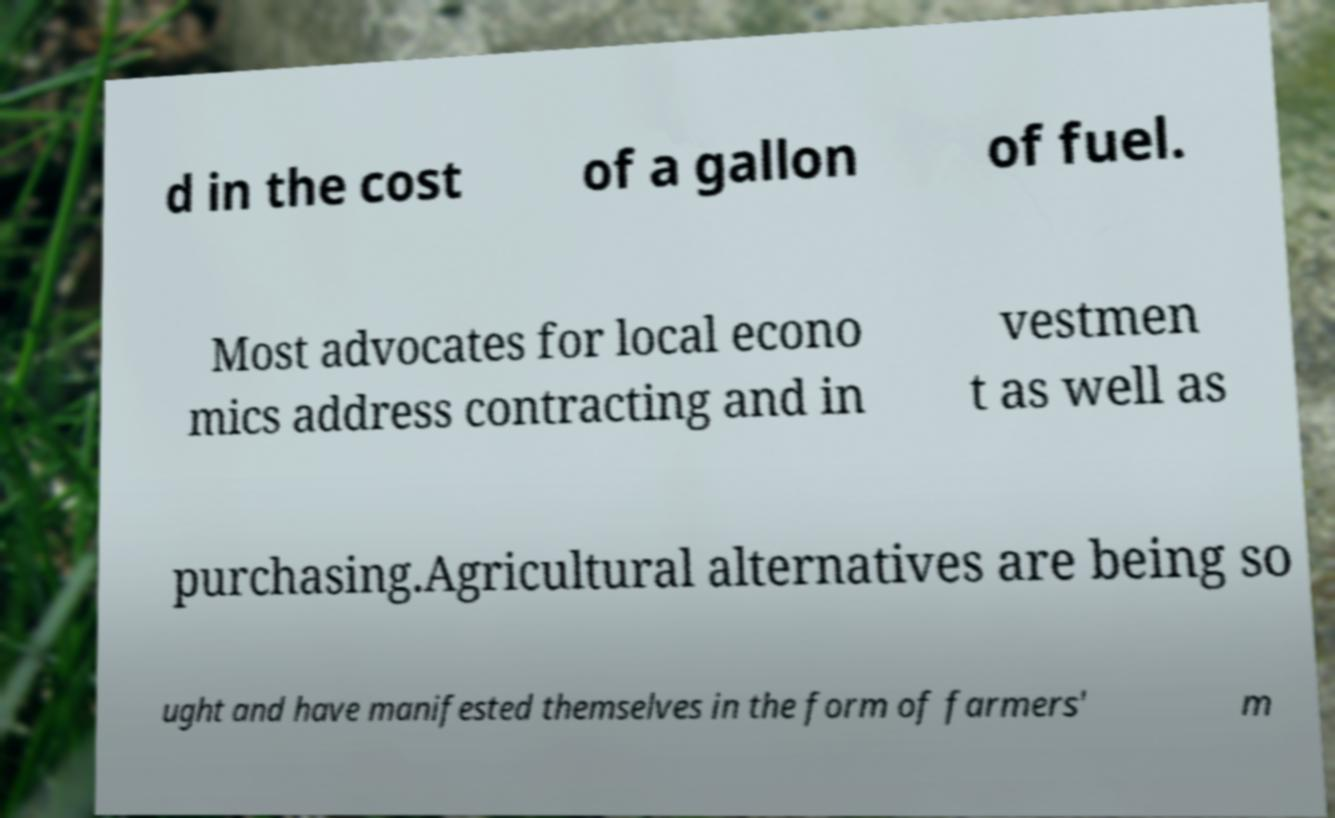Could you assist in decoding the text presented in this image and type it out clearly? d in the cost of a gallon of fuel. Most advocates for local econo mics address contracting and in vestmen t as well as purchasing.Agricultural alternatives are being so ught and have manifested themselves in the form of farmers' m 